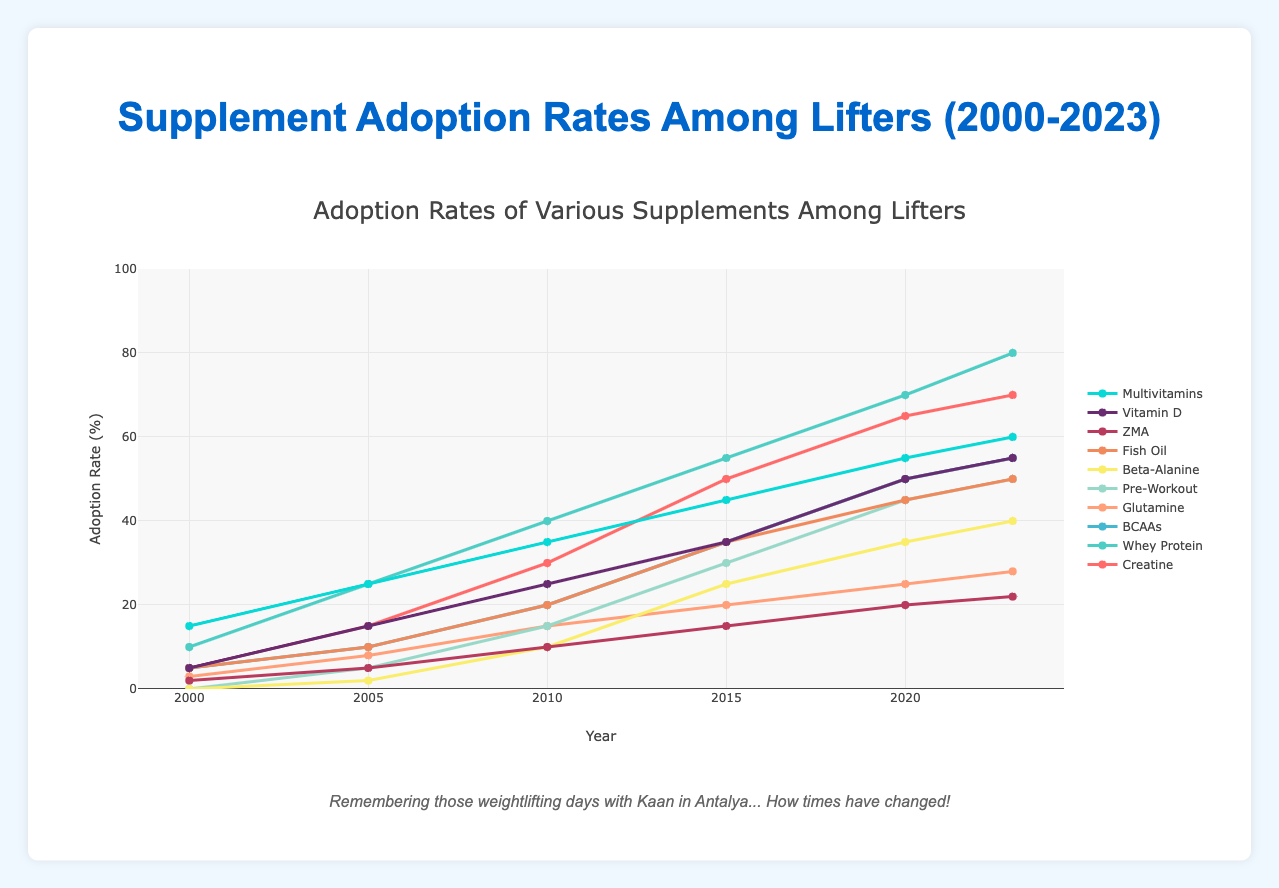What is the adoption rate of Whey Protein in 2023? To find the adoption rate of Whey Protein in 2023, locate the year 2023 on the X-axis and follow it up to the Whey Protein curve on the graph. According to the data, the adoption rate for Whey Protein in 2023 is 80%.
Answer: 80% Which supplement had the highest adoption rate in 2000? Check the adoption rates for all supplements in the year 2000. Creatine: 5%, Whey Protein: 10%, BCAAs: 5%, Glutamine: 3%, Pre-Workout: 0%, Beta-Alanine: 0%, Fish Oil: 5%, ZMA: 2%, Vitamin D: 5%, Multivitamins: 15%. Multivitamins had the highest adoption rate at 15%.
Answer: Multivitamins Between 2005 and 2010, which supplement showed the biggest increase in adoption rate? Compare the adoption rates in 2005 and 2010 for each supplement and calculate the differences. Creatine: 15% to 30% (15%), Whey Protein: 25% to 40% (15%), BCAAs: 10% to 20% (10%), Glutamine: 8% to 15% (7%), Pre-Workout: 5% to 15% (10%), Beta-Alanine: 2% to 10% (8%), Fish Oil: 10% to 20% (10%), ZMA: 5% to 10% (5%), Vitamin D: 15% to 25% (10%), Multivitamins: 25% to 35% (10%). Creatine and Whey Protein both showed the biggest increase of 15%.
Answer: Creatine and Whey Protein What is the average adoption rate of Fish Oil over the years shown in the figure? To find the average adoption rate of Fish Oil over the years, sum the adoption rates and then divide by the number of years: (5 + 10 + 20 + 35 + 45 + 50)/6 = 27.5%
Answer: 27.5% Is the adoption rate of Beta-Alanine in 2020 higher or lower than that of Pre-Workout in 2015? Check the adoption rates: Beta-Alanine in 2020 is 35%, and Pre-Workout in 2015 is 30%. Since 35% > 30%, Beta-Alanine's adoption rate in 2020 is higher.
Answer: Higher Which supplement had the lowest adoption rate in 2023, and what was the rate? Check the adoption rates for all supplements in 2023: Creatine: 70%, Whey Protein: 80%, BCAAs: 55%, Glutamine: 28%, Pre-Workout: 50%, Beta-Alanine: 40%, Fish Oil: 50%, ZMA: 22%, Vitamin D: 55%, Multivitamins: 60%. ZMA had the lowest adoption rate at 22%.
Answer: ZMA, 22% What is the difference between the adoption rates of Vitamin D and Glutamine in 2023? Locate the adoption rates of both Vitamin D (55%) and Glutamine (28%) in 2023, then subtract: 55% - 28% = 27%.
Answer: 27% What trends can be observed in the adoption rates of Creatine and Beta-Alanine over the years? Both supplements show an increasing trend over the years. Creatine starts at 5% in 2000 and climbs steadily to 70% in 2023. Beta-Alanine begins at 0% in 2000 and increases to 40% in 2023.
Answer: Increasing trend Among all supplements, which one had the most consistent increase in adoption rates from 2000 to 2023? To determine which supplement had the most consistent increase, observe the lines representing each supplement. Whey Protein shows a steady increase without sudden spikes or drops: 10% (2000), 25% (2005), 40% (2010), 55% (2015), 70% (2020), and 80% (2023).
Answer: Whey Protein 